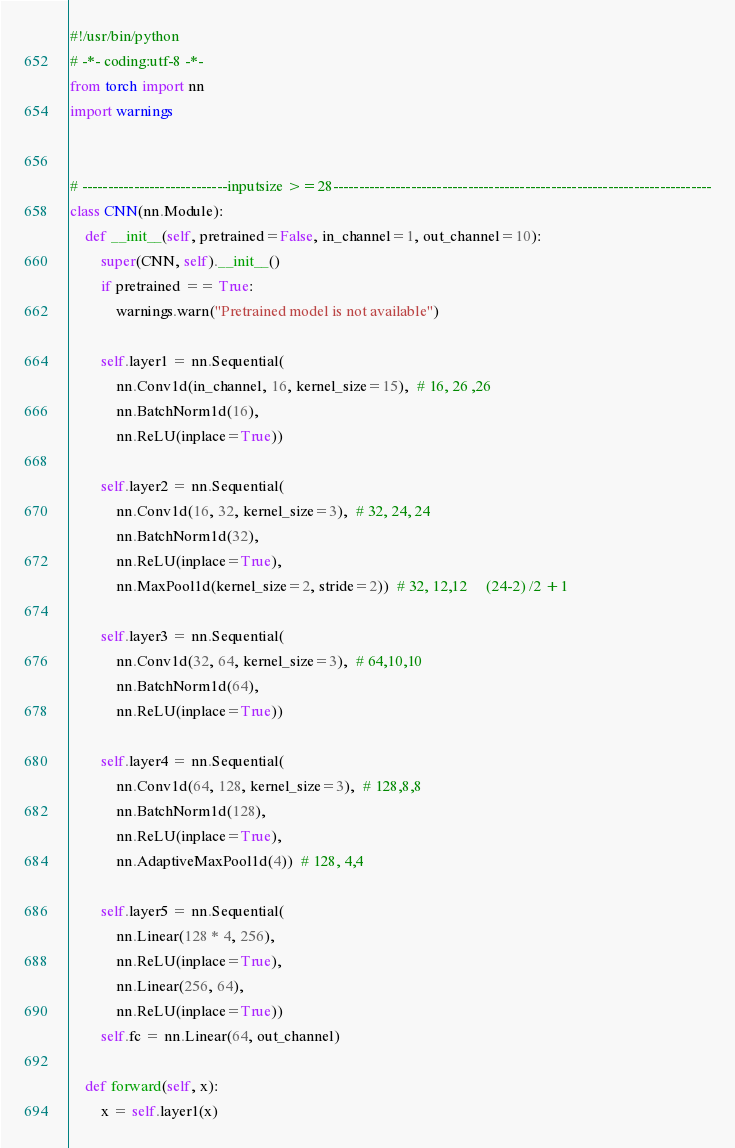<code> <loc_0><loc_0><loc_500><loc_500><_Python_>#!/usr/bin/python
# -*- coding:utf-8 -*-
from torch import nn
import warnings


# ----------------------------inputsize >=28-------------------------------------------------------------------------
class CNN(nn.Module):
    def __init__(self, pretrained=False, in_channel=1, out_channel=10):
        super(CNN, self).__init__()
        if pretrained == True:
            warnings.warn("Pretrained model is not available")

        self.layer1 = nn.Sequential(
            nn.Conv1d(in_channel, 16, kernel_size=15),  # 16, 26 ,26
            nn.BatchNorm1d(16),
            nn.ReLU(inplace=True))

        self.layer2 = nn.Sequential(
            nn.Conv1d(16, 32, kernel_size=3),  # 32, 24, 24
            nn.BatchNorm1d(32),
            nn.ReLU(inplace=True),
            nn.MaxPool1d(kernel_size=2, stride=2))  # 32, 12,12     (24-2) /2 +1

        self.layer3 = nn.Sequential(
            nn.Conv1d(32, 64, kernel_size=3),  # 64,10,10
            nn.BatchNorm1d(64),
            nn.ReLU(inplace=True))

        self.layer4 = nn.Sequential(
            nn.Conv1d(64, 128, kernel_size=3),  # 128,8,8
            nn.BatchNorm1d(128),
            nn.ReLU(inplace=True),
            nn.AdaptiveMaxPool1d(4))  # 128, 4,4

        self.layer5 = nn.Sequential(
            nn.Linear(128 * 4, 256),
            nn.ReLU(inplace=True),
            nn.Linear(256, 64),
            nn.ReLU(inplace=True))
        self.fc = nn.Linear(64, out_channel)

    def forward(self, x):
        x = self.layer1(x)</code> 